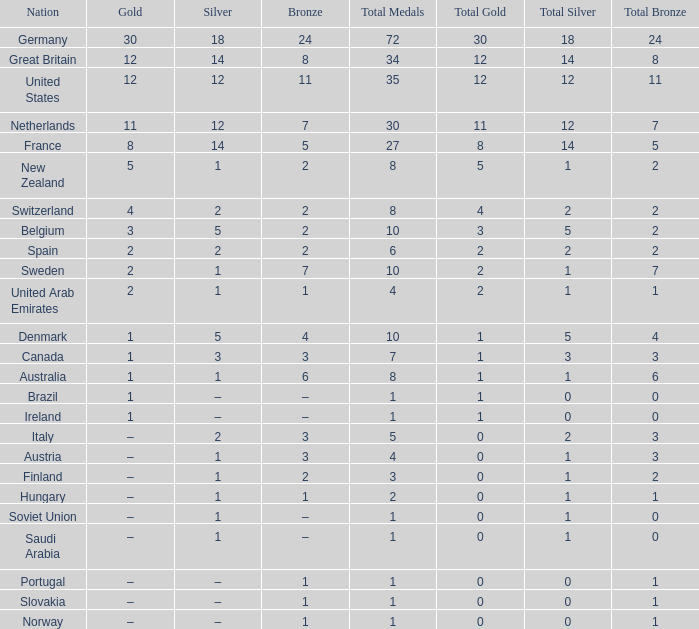What is the overall sum of total when silver equals 1 and bronze equals 7? 1.0. 